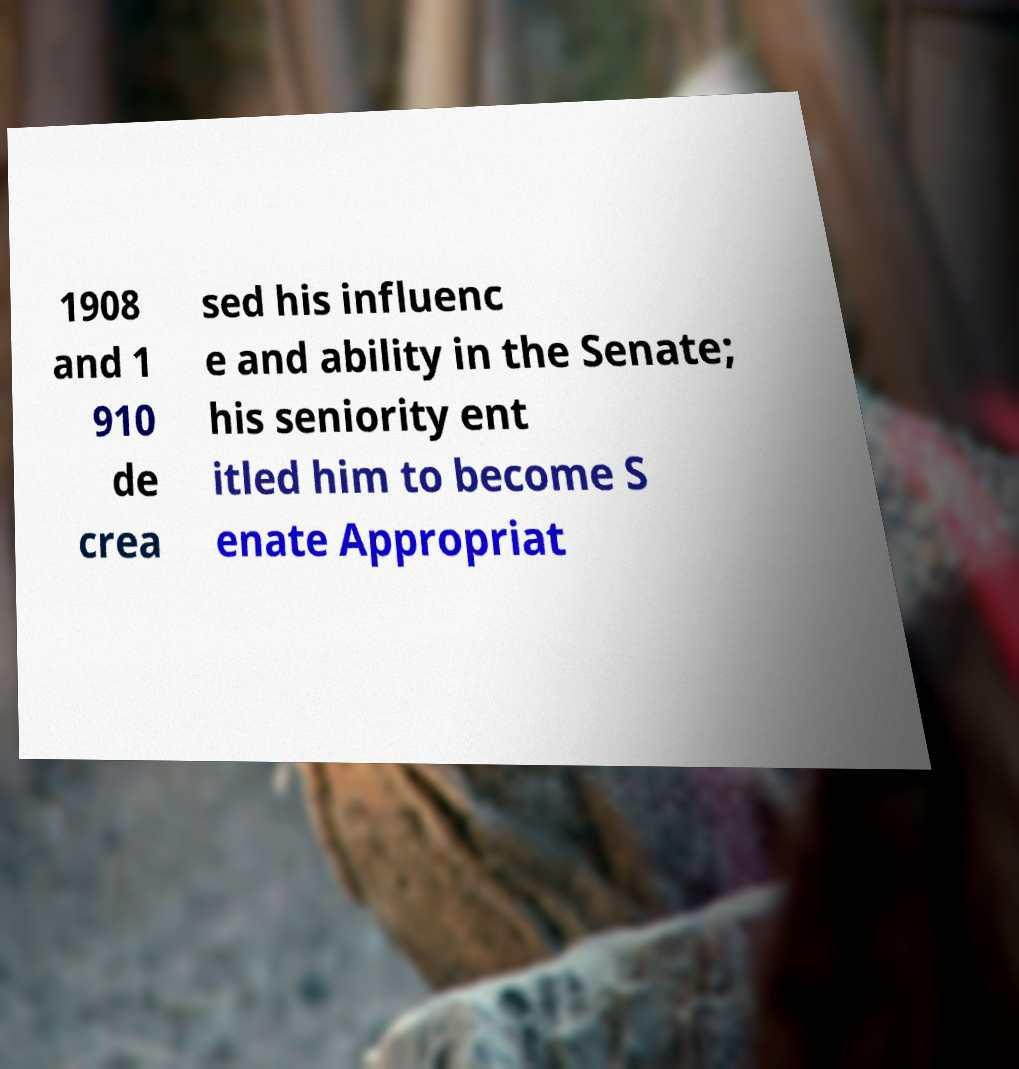Could you assist in decoding the text presented in this image and type it out clearly? 1908 and 1 910 de crea sed his influenc e and ability in the Senate; his seniority ent itled him to become S enate Appropriat 